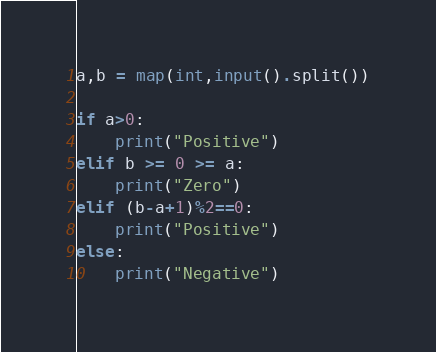<code> <loc_0><loc_0><loc_500><loc_500><_Python_>a,b = map(int,input().split())

if a>0:
    print("Positive")
elif b >= 0 >= a:
    print("Zero")
elif (b-a+1)%2==0:
    print("Positive")
else:
    print("Negative")</code> 